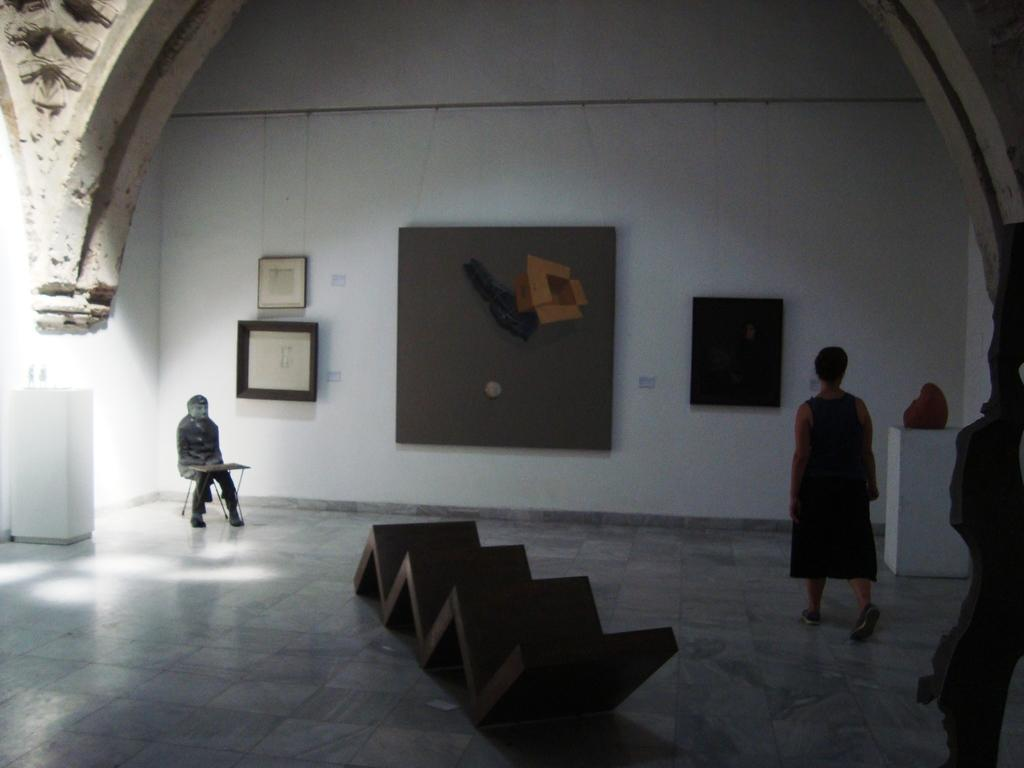How many people are present in the image? There are two people in the image. What can be seen on the wall in the image? There are frames on the wall. What object is on the floor in the image? There is a ladder-like object on the floor. What type of berry is being used to create the frames on the wall? There is no berry present in the image, and the frames on the wall are not made of berries. 